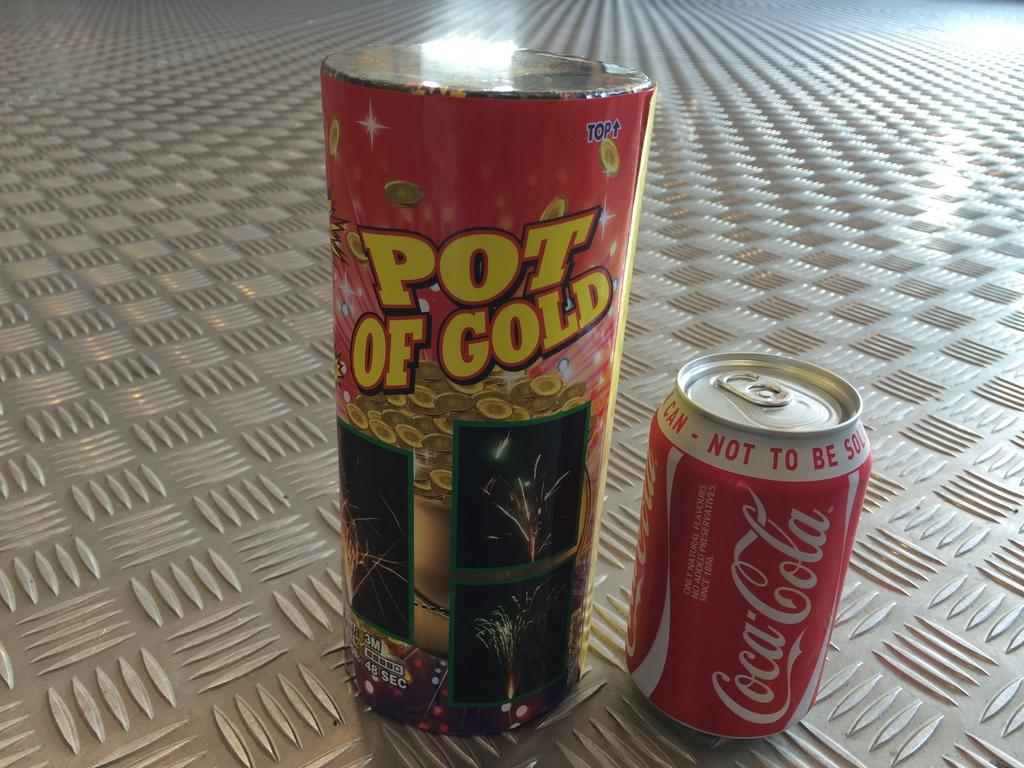<image>
Offer a succinct explanation of the picture presented. A can of Coca-Cola is next to a can of fireworks that says Pot of Gold. 